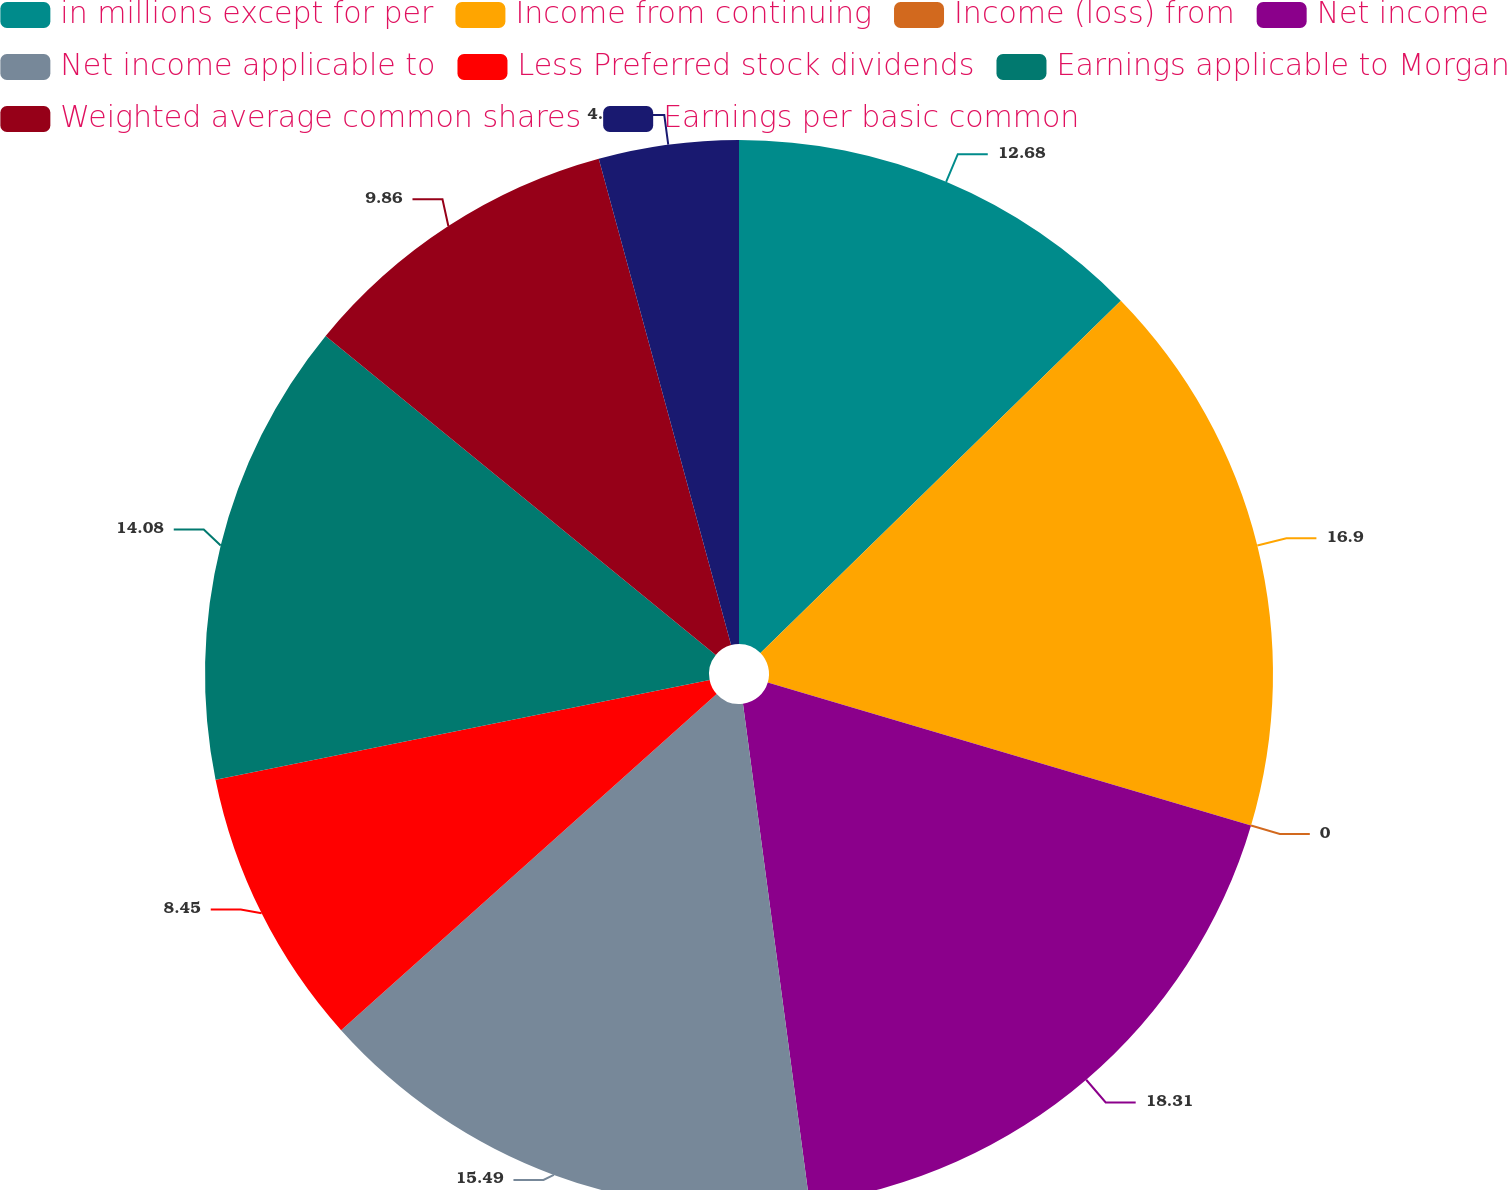<chart> <loc_0><loc_0><loc_500><loc_500><pie_chart><fcel>in millions except for per<fcel>Income from continuing<fcel>Income (loss) from<fcel>Net income<fcel>Net income applicable to<fcel>Less Preferred stock dividends<fcel>Earnings applicable to Morgan<fcel>Weighted average common shares<fcel>Earnings per basic common<nl><fcel>12.68%<fcel>16.9%<fcel>0.0%<fcel>18.31%<fcel>15.49%<fcel>8.45%<fcel>14.08%<fcel>9.86%<fcel>4.23%<nl></chart> 